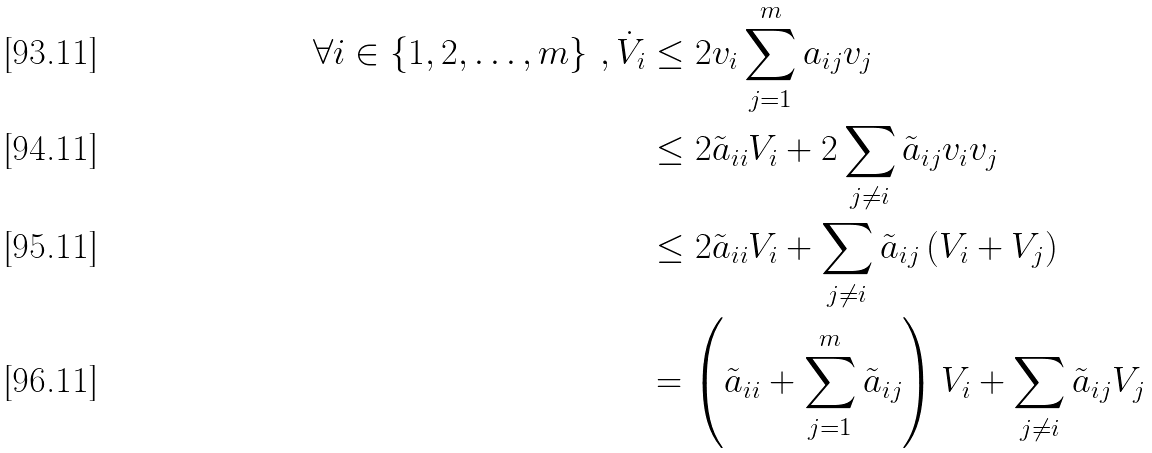<formula> <loc_0><loc_0><loc_500><loc_500>\forall i \in \left \{ 1 , 2 , \dots , m \right \} \, , \dot { V } _ { i } & \leq 2 v _ { i } \sum _ { j = 1 } ^ { m } a _ { i j } v _ { j } \\ & \leq 2 \tilde { a } _ { i i } V _ { i } + 2 \sum _ { j \neq i } \tilde { a } _ { i j } v _ { i } v _ { j } \\ & \leq 2 \tilde { a } _ { i i } V _ { i } + \sum _ { j \neq i } \tilde { a } _ { i j } \left ( V _ { i } + V _ { j } \right ) \\ & = \left ( \tilde { a } _ { i i } + \sum _ { j = 1 } ^ { m } \tilde { a } _ { i j } \right ) V _ { i } + \sum _ { j \neq i } \tilde { a } _ { i j } V _ { j }</formula> 